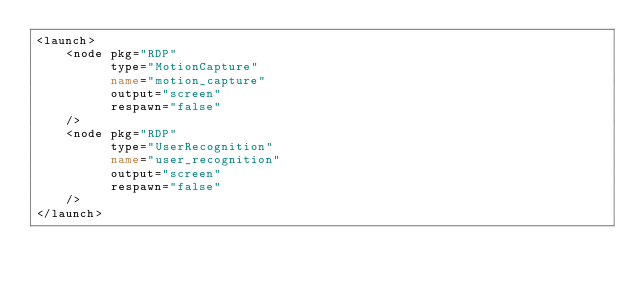<code> <loc_0><loc_0><loc_500><loc_500><_XML_><launch>
	<node pkg="RDP"
		  type="MotionCapture"
		  name="motion_capture"
		  output="screen"
		  respawn="false"
    />
	<node pkg="RDP"
	      type="UserRecognition"
		  name="user_recognition"
		  output="screen"
		  respawn="false"
    />
</launch>

</code> 